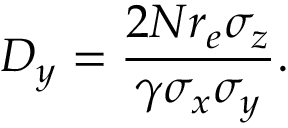Convert formula to latex. <formula><loc_0><loc_0><loc_500><loc_500>D _ { y } = \frac { 2 N r _ { e } \sigma _ { z } } { \gamma \sigma _ { x } \sigma _ { y } } .</formula> 